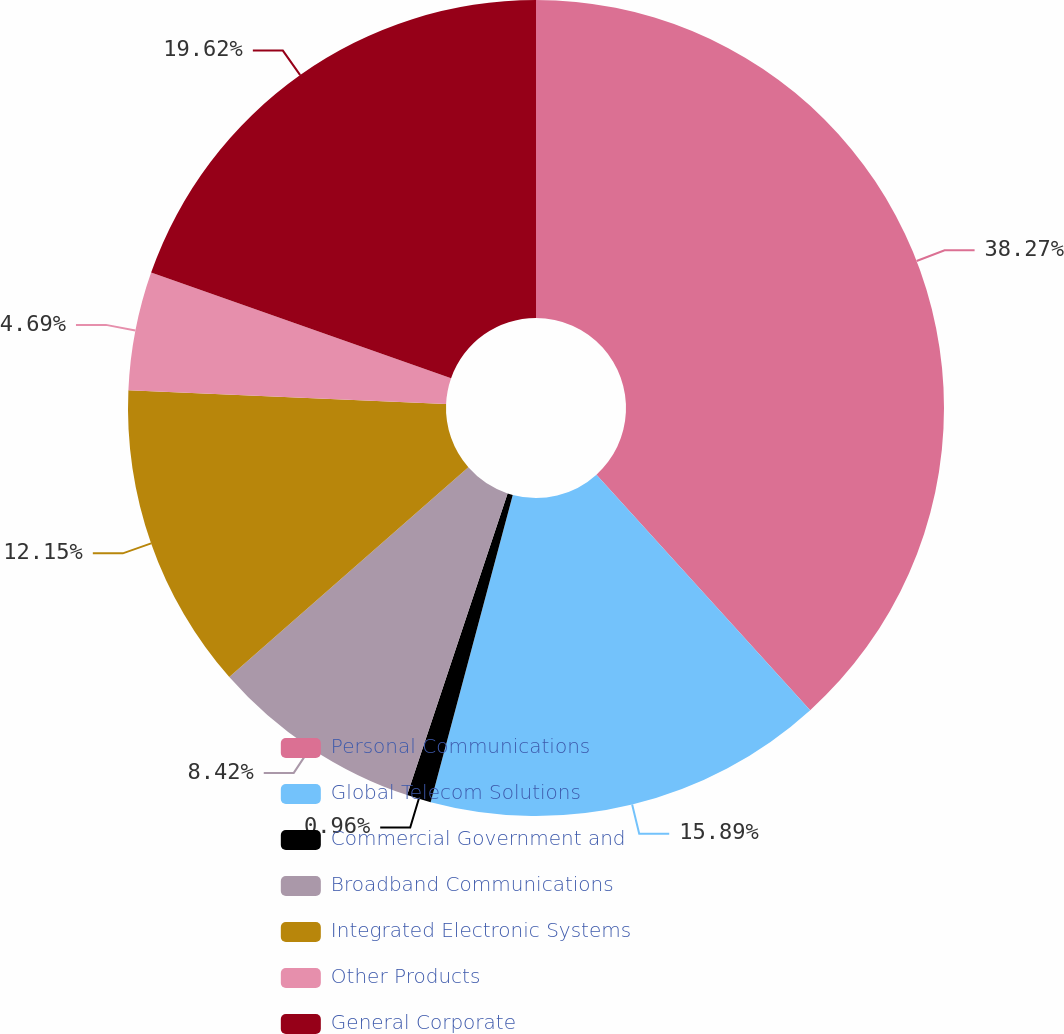Convert chart. <chart><loc_0><loc_0><loc_500><loc_500><pie_chart><fcel>Personal Communications<fcel>Global Telecom Solutions<fcel>Commercial Government and<fcel>Broadband Communications<fcel>Integrated Electronic Systems<fcel>Other Products<fcel>General Corporate<nl><fcel>38.26%<fcel>15.88%<fcel>0.96%<fcel>8.42%<fcel>12.15%<fcel>4.69%<fcel>19.61%<nl></chart> 